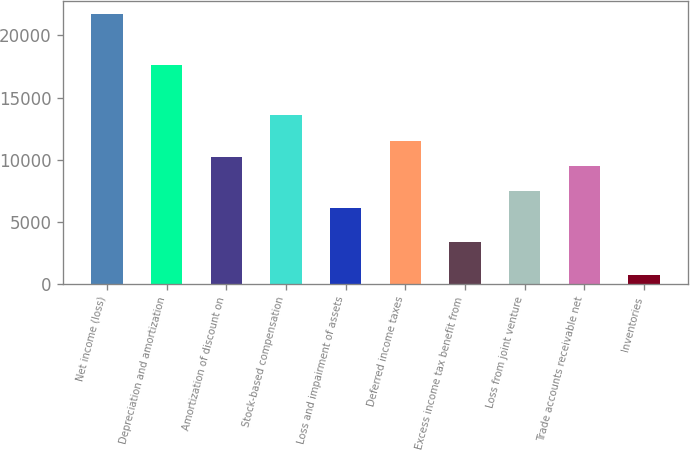<chart> <loc_0><loc_0><loc_500><loc_500><bar_chart><fcel>Net income (loss)<fcel>Depreciation and amortization<fcel>Amortization of discount on<fcel>Stock-based compensation<fcel>Loss and impairment of assets<fcel>Deferred income taxes<fcel>Excess income tax benefit from<fcel>Loss from joint venture<fcel>Trade accounts receivable net<fcel>Inventories<nl><fcel>21710.8<fcel>17640.4<fcel>10178<fcel>13570<fcel>6107.6<fcel>11534.8<fcel>3394<fcel>7464.4<fcel>9499.6<fcel>680.4<nl></chart> 